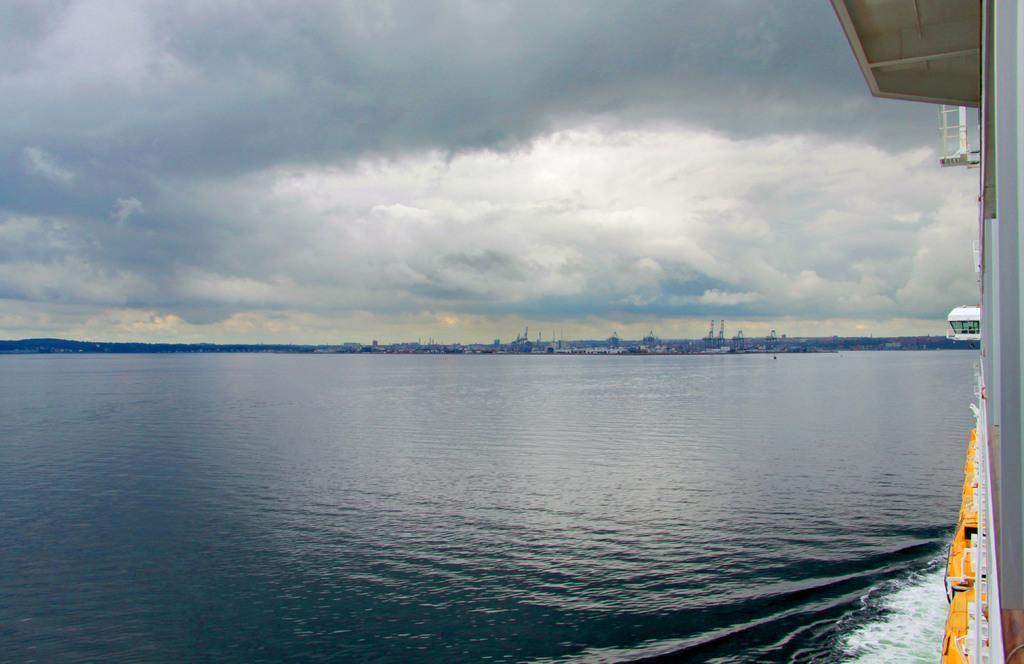Can you describe this image briefly? This image consists of water. On the right, it looks like a boat. At the top, there are clouds in the sky. 